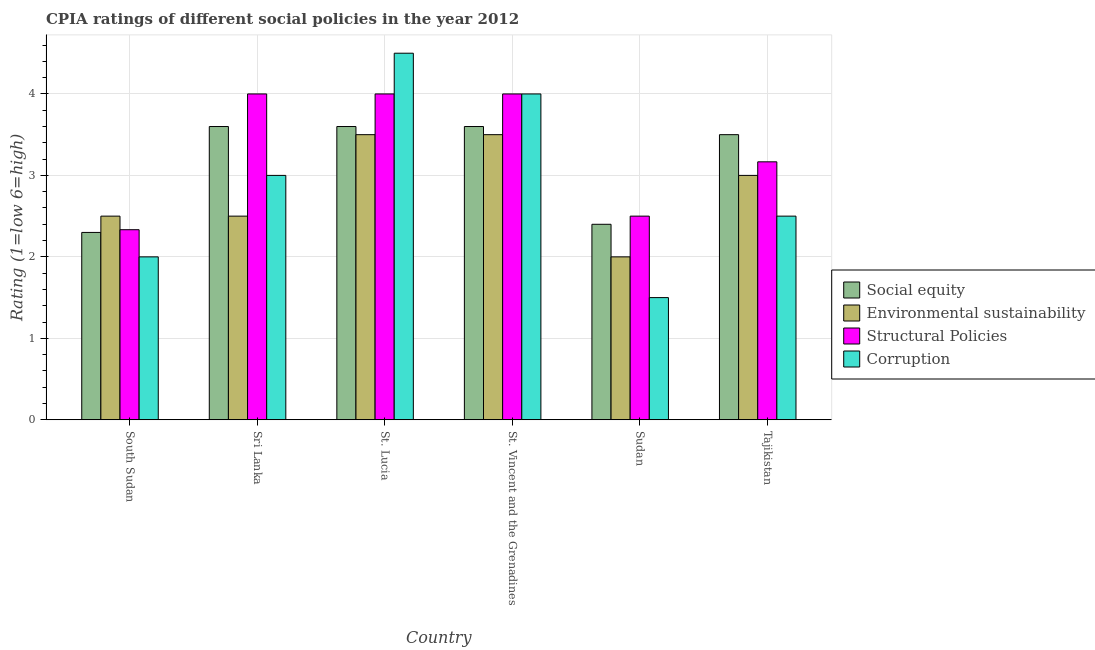How many different coloured bars are there?
Keep it short and to the point. 4. Are the number of bars per tick equal to the number of legend labels?
Your response must be concise. Yes. How many bars are there on the 6th tick from the left?
Your response must be concise. 4. How many bars are there on the 2nd tick from the right?
Your answer should be very brief. 4. What is the label of the 5th group of bars from the left?
Offer a terse response. Sudan. In which country was the cpia rating of structural policies maximum?
Your response must be concise. Sri Lanka. In which country was the cpia rating of social equity minimum?
Give a very brief answer. South Sudan. What is the total cpia rating of environmental sustainability in the graph?
Your response must be concise. 17. What is the difference between the cpia rating of environmental sustainability in Sri Lanka and the cpia rating of corruption in South Sudan?
Your response must be concise. 0.5. What is the average cpia rating of social equity per country?
Provide a short and direct response. 3.17. What is the difference between the cpia rating of social equity and cpia rating of corruption in Sudan?
Your answer should be compact. 0.9. In how many countries, is the cpia rating of structural policies greater than 4.4 ?
Keep it short and to the point. 0. What is the ratio of the cpia rating of social equity in South Sudan to that in St. Lucia?
Ensure brevity in your answer.  0.64. Is the cpia rating of corruption in South Sudan less than that in St. Vincent and the Grenadines?
Your answer should be very brief. Yes. What does the 4th bar from the left in Sri Lanka represents?
Your response must be concise. Corruption. What does the 1st bar from the right in Sudan represents?
Offer a very short reply. Corruption. Is it the case that in every country, the sum of the cpia rating of social equity and cpia rating of environmental sustainability is greater than the cpia rating of structural policies?
Offer a very short reply. Yes. What is the difference between two consecutive major ticks on the Y-axis?
Your answer should be compact. 1. Are the values on the major ticks of Y-axis written in scientific E-notation?
Provide a succinct answer. No. Does the graph contain any zero values?
Make the answer very short. No. Does the graph contain grids?
Give a very brief answer. Yes. How many legend labels are there?
Ensure brevity in your answer.  4. How are the legend labels stacked?
Provide a short and direct response. Vertical. What is the title of the graph?
Your answer should be compact. CPIA ratings of different social policies in the year 2012. Does "Social Protection" appear as one of the legend labels in the graph?
Make the answer very short. No. What is the label or title of the X-axis?
Provide a succinct answer. Country. What is the Rating (1=low 6=high) in Social equity in South Sudan?
Your answer should be very brief. 2.3. What is the Rating (1=low 6=high) of Structural Policies in South Sudan?
Provide a succinct answer. 2.33. What is the Rating (1=low 6=high) in Environmental sustainability in Sri Lanka?
Your answer should be very brief. 2.5. What is the Rating (1=low 6=high) in Corruption in Sri Lanka?
Offer a terse response. 3. What is the Rating (1=low 6=high) of Structural Policies in St. Lucia?
Give a very brief answer. 4. What is the Rating (1=low 6=high) in Environmental sustainability in St. Vincent and the Grenadines?
Ensure brevity in your answer.  3.5. What is the Rating (1=low 6=high) in Environmental sustainability in Sudan?
Offer a terse response. 2. What is the Rating (1=low 6=high) in Structural Policies in Tajikistan?
Keep it short and to the point. 3.17. Across all countries, what is the maximum Rating (1=low 6=high) of Environmental sustainability?
Provide a succinct answer. 3.5. Across all countries, what is the maximum Rating (1=low 6=high) in Structural Policies?
Give a very brief answer. 4. Across all countries, what is the minimum Rating (1=low 6=high) of Environmental sustainability?
Your response must be concise. 2. Across all countries, what is the minimum Rating (1=low 6=high) in Structural Policies?
Provide a short and direct response. 2.33. Across all countries, what is the minimum Rating (1=low 6=high) of Corruption?
Your answer should be compact. 1.5. What is the total Rating (1=low 6=high) of Environmental sustainability in the graph?
Ensure brevity in your answer.  17. What is the total Rating (1=low 6=high) of Structural Policies in the graph?
Offer a terse response. 20. What is the total Rating (1=low 6=high) in Corruption in the graph?
Your answer should be compact. 17.5. What is the difference between the Rating (1=low 6=high) in Structural Policies in South Sudan and that in Sri Lanka?
Offer a very short reply. -1.67. What is the difference between the Rating (1=low 6=high) of Social equity in South Sudan and that in St. Lucia?
Offer a terse response. -1.3. What is the difference between the Rating (1=low 6=high) of Structural Policies in South Sudan and that in St. Lucia?
Your answer should be very brief. -1.67. What is the difference between the Rating (1=low 6=high) in Environmental sustainability in South Sudan and that in St. Vincent and the Grenadines?
Give a very brief answer. -1. What is the difference between the Rating (1=low 6=high) of Structural Policies in South Sudan and that in St. Vincent and the Grenadines?
Your response must be concise. -1.67. What is the difference between the Rating (1=low 6=high) in Corruption in South Sudan and that in St. Vincent and the Grenadines?
Give a very brief answer. -2. What is the difference between the Rating (1=low 6=high) in Social equity in South Sudan and that in Sudan?
Make the answer very short. -0.1. What is the difference between the Rating (1=low 6=high) in Environmental sustainability in South Sudan and that in Sudan?
Provide a short and direct response. 0.5. What is the difference between the Rating (1=low 6=high) of Structural Policies in South Sudan and that in Sudan?
Offer a terse response. -0.17. What is the difference between the Rating (1=low 6=high) of Structural Policies in South Sudan and that in Tajikistan?
Give a very brief answer. -0.83. What is the difference between the Rating (1=low 6=high) of Corruption in South Sudan and that in Tajikistan?
Ensure brevity in your answer.  -0.5. What is the difference between the Rating (1=low 6=high) of Social equity in Sri Lanka and that in St. Lucia?
Ensure brevity in your answer.  0. What is the difference between the Rating (1=low 6=high) in Environmental sustainability in Sri Lanka and that in St. Lucia?
Provide a succinct answer. -1. What is the difference between the Rating (1=low 6=high) of Corruption in Sri Lanka and that in St. Lucia?
Give a very brief answer. -1.5. What is the difference between the Rating (1=low 6=high) in Social equity in Sri Lanka and that in St. Vincent and the Grenadines?
Your answer should be compact. 0. What is the difference between the Rating (1=low 6=high) in Environmental sustainability in Sri Lanka and that in St. Vincent and the Grenadines?
Your answer should be compact. -1. What is the difference between the Rating (1=low 6=high) in Corruption in Sri Lanka and that in St. Vincent and the Grenadines?
Provide a short and direct response. -1. What is the difference between the Rating (1=low 6=high) in Structural Policies in Sri Lanka and that in Sudan?
Keep it short and to the point. 1.5. What is the difference between the Rating (1=low 6=high) of Social equity in Sri Lanka and that in Tajikistan?
Give a very brief answer. 0.1. What is the difference between the Rating (1=low 6=high) in Environmental sustainability in Sri Lanka and that in Tajikistan?
Offer a terse response. -0.5. What is the difference between the Rating (1=low 6=high) of Structural Policies in Sri Lanka and that in Tajikistan?
Give a very brief answer. 0.83. What is the difference between the Rating (1=low 6=high) of Corruption in Sri Lanka and that in Tajikistan?
Give a very brief answer. 0.5. What is the difference between the Rating (1=low 6=high) of Social equity in St. Lucia and that in St. Vincent and the Grenadines?
Ensure brevity in your answer.  0. What is the difference between the Rating (1=low 6=high) in Corruption in St. Lucia and that in St. Vincent and the Grenadines?
Your answer should be very brief. 0.5. What is the difference between the Rating (1=low 6=high) in Social equity in St. Lucia and that in Sudan?
Provide a succinct answer. 1.2. What is the difference between the Rating (1=low 6=high) in Environmental sustainability in St. Lucia and that in Sudan?
Provide a short and direct response. 1.5. What is the difference between the Rating (1=low 6=high) in Corruption in St. Lucia and that in Sudan?
Provide a succinct answer. 3. What is the difference between the Rating (1=low 6=high) in Environmental sustainability in St. Lucia and that in Tajikistan?
Make the answer very short. 0.5. What is the difference between the Rating (1=low 6=high) in Environmental sustainability in St. Vincent and the Grenadines and that in Sudan?
Make the answer very short. 1.5. What is the difference between the Rating (1=low 6=high) in Corruption in St. Vincent and the Grenadines and that in Tajikistan?
Your answer should be compact. 1.5. What is the difference between the Rating (1=low 6=high) of Social equity in Sudan and that in Tajikistan?
Provide a short and direct response. -1.1. What is the difference between the Rating (1=low 6=high) of Environmental sustainability in Sudan and that in Tajikistan?
Provide a short and direct response. -1. What is the difference between the Rating (1=low 6=high) of Structural Policies in Sudan and that in Tajikistan?
Provide a succinct answer. -0.67. What is the difference between the Rating (1=low 6=high) of Corruption in Sudan and that in Tajikistan?
Your response must be concise. -1. What is the difference between the Rating (1=low 6=high) of Social equity in South Sudan and the Rating (1=low 6=high) of Environmental sustainability in Sri Lanka?
Your response must be concise. -0.2. What is the difference between the Rating (1=low 6=high) of Social equity in South Sudan and the Rating (1=low 6=high) of Corruption in Sri Lanka?
Make the answer very short. -0.7. What is the difference between the Rating (1=low 6=high) in Environmental sustainability in South Sudan and the Rating (1=low 6=high) in Corruption in Sri Lanka?
Offer a very short reply. -0.5. What is the difference between the Rating (1=low 6=high) in Structural Policies in South Sudan and the Rating (1=low 6=high) in Corruption in Sri Lanka?
Provide a short and direct response. -0.67. What is the difference between the Rating (1=low 6=high) in Social equity in South Sudan and the Rating (1=low 6=high) in Structural Policies in St. Lucia?
Keep it short and to the point. -1.7. What is the difference between the Rating (1=low 6=high) in Structural Policies in South Sudan and the Rating (1=low 6=high) in Corruption in St. Lucia?
Your response must be concise. -2.17. What is the difference between the Rating (1=low 6=high) of Social equity in South Sudan and the Rating (1=low 6=high) of Corruption in St. Vincent and the Grenadines?
Keep it short and to the point. -1.7. What is the difference between the Rating (1=low 6=high) in Structural Policies in South Sudan and the Rating (1=low 6=high) in Corruption in St. Vincent and the Grenadines?
Your answer should be very brief. -1.67. What is the difference between the Rating (1=low 6=high) in Social equity in South Sudan and the Rating (1=low 6=high) in Environmental sustainability in Sudan?
Make the answer very short. 0.3. What is the difference between the Rating (1=low 6=high) in Environmental sustainability in South Sudan and the Rating (1=low 6=high) in Structural Policies in Sudan?
Offer a very short reply. 0. What is the difference between the Rating (1=low 6=high) in Structural Policies in South Sudan and the Rating (1=low 6=high) in Corruption in Sudan?
Your answer should be compact. 0.83. What is the difference between the Rating (1=low 6=high) of Social equity in South Sudan and the Rating (1=low 6=high) of Environmental sustainability in Tajikistan?
Your answer should be compact. -0.7. What is the difference between the Rating (1=low 6=high) in Social equity in South Sudan and the Rating (1=low 6=high) in Structural Policies in Tajikistan?
Keep it short and to the point. -0.87. What is the difference between the Rating (1=low 6=high) of Structural Policies in South Sudan and the Rating (1=low 6=high) of Corruption in Tajikistan?
Give a very brief answer. -0.17. What is the difference between the Rating (1=low 6=high) in Social equity in Sri Lanka and the Rating (1=low 6=high) in Environmental sustainability in St. Lucia?
Offer a very short reply. 0.1. What is the difference between the Rating (1=low 6=high) in Social equity in Sri Lanka and the Rating (1=low 6=high) in Structural Policies in St. Lucia?
Your answer should be compact. -0.4. What is the difference between the Rating (1=low 6=high) in Environmental sustainability in Sri Lanka and the Rating (1=low 6=high) in Structural Policies in St. Lucia?
Your answer should be compact. -1.5. What is the difference between the Rating (1=low 6=high) of Environmental sustainability in Sri Lanka and the Rating (1=low 6=high) of Corruption in St. Lucia?
Provide a short and direct response. -2. What is the difference between the Rating (1=low 6=high) in Structural Policies in Sri Lanka and the Rating (1=low 6=high) in Corruption in St. Lucia?
Offer a terse response. -0.5. What is the difference between the Rating (1=low 6=high) in Social equity in Sri Lanka and the Rating (1=low 6=high) in Structural Policies in St. Vincent and the Grenadines?
Keep it short and to the point. -0.4. What is the difference between the Rating (1=low 6=high) of Social equity in Sri Lanka and the Rating (1=low 6=high) of Corruption in St. Vincent and the Grenadines?
Provide a short and direct response. -0.4. What is the difference between the Rating (1=low 6=high) of Environmental sustainability in Sri Lanka and the Rating (1=low 6=high) of Structural Policies in St. Vincent and the Grenadines?
Your answer should be very brief. -1.5. What is the difference between the Rating (1=low 6=high) in Structural Policies in Sri Lanka and the Rating (1=low 6=high) in Corruption in St. Vincent and the Grenadines?
Offer a terse response. 0. What is the difference between the Rating (1=low 6=high) of Social equity in Sri Lanka and the Rating (1=low 6=high) of Environmental sustainability in Sudan?
Offer a very short reply. 1.6. What is the difference between the Rating (1=low 6=high) of Social equity in Sri Lanka and the Rating (1=low 6=high) of Structural Policies in Sudan?
Provide a succinct answer. 1.1. What is the difference between the Rating (1=low 6=high) in Environmental sustainability in Sri Lanka and the Rating (1=low 6=high) in Structural Policies in Sudan?
Ensure brevity in your answer.  0. What is the difference between the Rating (1=low 6=high) of Structural Policies in Sri Lanka and the Rating (1=low 6=high) of Corruption in Sudan?
Give a very brief answer. 2.5. What is the difference between the Rating (1=low 6=high) in Social equity in Sri Lanka and the Rating (1=low 6=high) in Structural Policies in Tajikistan?
Your response must be concise. 0.43. What is the difference between the Rating (1=low 6=high) in Social equity in Sri Lanka and the Rating (1=low 6=high) in Corruption in Tajikistan?
Offer a terse response. 1.1. What is the difference between the Rating (1=low 6=high) in Environmental sustainability in Sri Lanka and the Rating (1=low 6=high) in Structural Policies in Tajikistan?
Keep it short and to the point. -0.67. What is the difference between the Rating (1=low 6=high) of Environmental sustainability in Sri Lanka and the Rating (1=low 6=high) of Corruption in Tajikistan?
Make the answer very short. 0. What is the difference between the Rating (1=low 6=high) in Structural Policies in Sri Lanka and the Rating (1=low 6=high) in Corruption in Tajikistan?
Your answer should be compact. 1.5. What is the difference between the Rating (1=low 6=high) in Social equity in St. Lucia and the Rating (1=low 6=high) in Structural Policies in St. Vincent and the Grenadines?
Provide a short and direct response. -0.4. What is the difference between the Rating (1=low 6=high) of Social equity in St. Lucia and the Rating (1=low 6=high) of Corruption in St. Vincent and the Grenadines?
Ensure brevity in your answer.  -0.4. What is the difference between the Rating (1=low 6=high) in Environmental sustainability in St. Lucia and the Rating (1=low 6=high) in Corruption in St. Vincent and the Grenadines?
Make the answer very short. -0.5. What is the difference between the Rating (1=low 6=high) in Social equity in St. Lucia and the Rating (1=low 6=high) in Environmental sustainability in Sudan?
Provide a short and direct response. 1.6. What is the difference between the Rating (1=low 6=high) in Social equity in St. Lucia and the Rating (1=low 6=high) in Structural Policies in Tajikistan?
Ensure brevity in your answer.  0.43. What is the difference between the Rating (1=low 6=high) of Social equity in St. Lucia and the Rating (1=low 6=high) of Corruption in Tajikistan?
Your response must be concise. 1.1. What is the difference between the Rating (1=low 6=high) of Social equity in St. Vincent and the Grenadines and the Rating (1=low 6=high) of Environmental sustainability in Sudan?
Give a very brief answer. 1.6. What is the difference between the Rating (1=low 6=high) of Social equity in St. Vincent and the Grenadines and the Rating (1=low 6=high) of Structural Policies in Sudan?
Provide a succinct answer. 1.1. What is the difference between the Rating (1=low 6=high) of Social equity in St. Vincent and the Grenadines and the Rating (1=low 6=high) of Structural Policies in Tajikistan?
Provide a short and direct response. 0.43. What is the difference between the Rating (1=low 6=high) in Environmental sustainability in St. Vincent and the Grenadines and the Rating (1=low 6=high) in Structural Policies in Tajikistan?
Your answer should be compact. 0.33. What is the difference between the Rating (1=low 6=high) in Environmental sustainability in St. Vincent and the Grenadines and the Rating (1=low 6=high) in Corruption in Tajikistan?
Ensure brevity in your answer.  1. What is the difference between the Rating (1=low 6=high) of Structural Policies in St. Vincent and the Grenadines and the Rating (1=low 6=high) of Corruption in Tajikistan?
Your answer should be very brief. 1.5. What is the difference between the Rating (1=low 6=high) of Social equity in Sudan and the Rating (1=low 6=high) of Environmental sustainability in Tajikistan?
Your answer should be compact. -0.6. What is the difference between the Rating (1=low 6=high) of Social equity in Sudan and the Rating (1=low 6=high) of Structural Policies in Tajikistan?
Offer a very short reply. -0.77. What is the difference between the Rating (1=low 6=high) in Environmental sustainability in Sudan and the Rating (1=low 6=high) in Structural Policies in Tajikistan?
Provide a short and direct response. -1.17. What is the difference between the Rating (1=low 6=high) in Environmental sustainability in Sudan and the Rating (1=low 6=high) in Corruption in Tajikistan?
Provide a succinct answer. -0.5. What is the difference between the Rating (1=low 6=high) in Structural Policies in Sudan and the Rating (1=low 6=high) in Corruption in Tajikistan?
Your answer should be compact. 0. What is the average Rating (1=low 6=high) of Social equity per country?
Give a very brief answer. 3.17. What is the average Rating (1=low 6=high) in Environmental sustainability per country?
Offer a very short reply. 2.83. What is the average Rating (1=low 6=high) of Corruption per country?
Offer a terse response. 2.92. What is the difference between the Rating (1=low 6=high) of Social equity and Rating (1=low 6=high) of Environmental sustainability in South Sudan?
Give a very brief answer. -0.2. What is the difference between the Rating (1=low 6=high) of Social equity and Rating (1=low 6=high) of Structural Policies in South Sudan?
Provide a short and direct response. -0.03. What is the difference between the Rating (1=low 6=high) in Environmental sustainability and Rating (1=low 6=high) in Structural Policies in South Sudan?
Offer a very short reply. 0.17. What is the difference between the Rating (1=low 6=high) of Environmental sustainability and Rating (1=low 6=high) of Corruption in South Sudan?
Your response must be concise. 0.5. What is the difference between the Rating (1=low 6=high) of Social equity and Rating (1=low 6=high) of Structural Policies in Sri Lanka?
Keep it short and to the point. -0.4. What is the difference between the Rating (1=low 6=high) of Social equity and Rating (1=low 6=high) of Environmental sustainability in St. Lucia?
Offer a terse response. 0.1. What is the difference between the Rating (1=low 6=high) in Social equity and Rating (1=low 6=high) in Structural Policies in St. Lucia?
Offer a terse response. -0.4. What is the difference between the Rating (1=low 6=high) of Social equity and Rating (1=low 6=high) of Corruption in St. Lucia?
Provide a succinct answer. -0.9. What is the difference between the Rating (1=low 6=high) of Environmental sustainability and Rating (1=low 6=high) of Structural Policies in St. Vincent and the Grenadines?
Provide a succinct answer. -0.5. What is the difference between the Rating (1=low 6=high) in Environmental sustainability and Rating (1=low 6=high) in Corruption in St. Vincent and the Grenadines?
Offer a very short reply. -0.5. What is the difference between the Rating (1=low 6=high) of Social equity and Rating (1=low 6=high) of Environmental sustainability in Sudan?
Offer a very short reply. 0.4. What is the difference between the Rating (1=low 6=high) in Social equity and Rating (1=low 6=high) in Corruption in Sudan?
Offer a terse response. 0.9. What is the difference between the Rating (1=low 6=high) of Environmental sustainability and Rating (1=low 6=high) of Structural Policies in Sudan?
Offer a very short reply. -0.5. What is the difference between the Rating (1=low 6=high) in Social equity and Rating (1=low 6=high) in Corruption in Tajikistan?
Offer a terse response. 1. What is the difference between the Rating (1=low 6=high) of Environmental sustainability and Rating (1=low 6=high) of Structural Policies in Tajikistan?
Give a very brief answer. -0.17. What is the difference between the Rating (1=low 6=high) in Environmental sustainability and Rating (1=low 6=high) in Corruption in Tajikistan?
Offer a terse response. 0.5. What is the difference between the Rating (1=low 6=high) of Structural Policies and Rating (1=low 6=high) of Corruption in Tajikistan?
Keep it short and to the point. 0.67. What is the ratio of the Rating (1=low 6=high) of Social equity in South Sudan to that in Sri Lanka?
Keep it short and to the point. 0.64. What is the ratio of the Rating (1=low 6=high) of Structural Policies in South Sudan to that in Sri Lanka?
Your response must be concise. 0.58. What is the ratio of the Rating (1=low 6=high) in Social equity in South Sudan to that in St. Lucia?
Ensure brevity in your answer.  0.64. What is the ratio of the Rating (1=low 6=high) in Environmental sustainability in South Sudan to that in St. Lucia?
Ensure brevity in your answer.  0.71. What is the ratio of the Rating (1=low 6=high) in Structural Policies in South Sudan to that in St. Lucia?
Keep it short and to the point. 0.58. What is the ratio of the Rating (1=low 6=high) of Corruption in South Sudan to that in St. Lucia?
Your response must be concise. 0.44. What is the ratio of the Rating (1=low 6=high) in Social equity in South Sudan to that in St. Vincent and the Grenadines?
Keep it short and to the point. 0.64. What is the ratio of the Rating (1=low 6=high) of Environmental sustainability in South Sudan to that in St. Vincent and the Grenadines?
Provide a short and direct response. 0.71. What is the ratio of the Rating (1=low 6=high) in Structural Policies in South Sudan to that in St. Vincent and the Grenadines?
Ensure brevity in your answer.  0.58. What is the ratio of the Rating (1=low 6=high) of Corruption in South Sudan to that in St. Vincent and the Grenadines?
Keep it short and to the point. 0.5. What is the ratio of the Rating (1=low 6=high) of Structural Policies in South Sudan to that in Sudan?
Ensure brevity in your answer.  0.93. What is the ratio of the Rating (1=low 6=high) in Social equity in South Sudan to that in Tajikistan?
Ensure brevity in your answer.  0.66. What is the ratio of the Rating (1=low 6=high) of Environmental sustainability in South Sudan to that in Tajikistan?
Your answer should be compact. 0.83. What is the ratio of the Rating (1=low 6=high) in Structural Policies in South Sudan to that in Tajikistan?
Your answer should be very brief. 0.74. What is the ratio of the Rating (1=low 6=high) of Corruption in South Sudan to that in Tajikistan?
Your response must be concise. 0.8. What is the ratio of the Rating (1=low 6=high) of Social equity in Sri Lanka to that in St. Lucia?
Your answer should be compact. 1. What is the ratio of the Rating (1=low 6=high) of Structural Policies in Sri Lanka to that in St. Lucia?
Make the answer very short. 1. What is the ratio of the Rating (1=low 6=high) in Environmental sustainability in Sri Lanka to that in Sudan?
Provide a succinct answer. 1.25. What is the ratio of the Rating (1=low 6=high) in Social equity in Sri Lanka to that in Tajikistan?
Provide a succinct answer. 1.03. What is the ratio of the Rating (1=low 6=high) of Environmental sustainability in Sri Lanka to that in Tajikistan?
Your answer should be compact. 0.83. What is the ratio of the Rating (1=low 6=high) in Structural Policies in Sri Lanka to that in Tajikistan?
Keep it short and to the point. 1.26. What is the ratio of the Rating (1=low 6=high) in Social equity in St. Lucia to that in St. Vincent and the Grenadines?
Make the answer very short. 1. What is the ratio of the Rating (1=low 6=high) of Environmental sustainability in St. Lucia to that in St. Vincent and the Grenadines?
Offer a terse response. 1. What is the ratio of the Rating (1=low 6=high) in Structural Policies in St. Lucia to that in St. Vincent and the Grenadines?
Keep it short and to the point. 1. What is the ratio of the Rating (1=low 6=high) in Corruption in St. Lucia to that in St. Vincent and the Grenadines?
Your response must be concise. 1.12. What is the ratio of the Rating (1=low 6=high) of Social equity in St. Lucia to that in Sudan?
Ensure brevity in your answer.  1.5. What is the ratio of the Rating (1=low 6=high) in Social equity in St. Lucia to that in Tajikistan?
Provide a short and direct response. 1.03. What is the ratio of the Rating (1=low 6=high) in Structural Policies in St. Lucia to that in Tajikistan?
Your answer should be compact. 1.26. What is the ratio of the Rating (1=low 6=high) in Corruption in St. Lucia to that in Tajikistan?
Offer a very short reply. 1.8. What is the ratio of the Rating (1=low 6=high) in Environmental sustainability in St. Vincent and the Grenadines to that in Sudan?
Keep it short and to the point. 1.75. What is the ratio of the Rating (1=low 6=high) of Structural Policies in St. Vincent and the Grenadines to that in Sudan?
Your response must be concise. 1.6. What is the ratio of the Rating (1=low 6=high) in Corruption in St. Vincent and the Grenadines to that in Sudan?
Give a very brief answer. 2.67. What is the ratio of the Rating (1=low 6=high) in Social equity in St. Vincent and the Grenadines to that in Tajikistan?
Your answer should be compact. 1.03. What is the ratio of the Rating (1=low 6=high) in Environmental sustainability in St. Vincent and the Grenadines to that in Tajikistan?
Offer a terse response. 1.17. What is the ratio of the Rating (1=low 6=high) in Structural Policies in St. Vincent and the Grenadines to that in Tajikistan?
Keep it short and to the point. 1.26. What is the ratio of the Rating (1=low 6=high) of Social equity in Sudan to that in Tajikistan?
Provide a succinct answer. 0.69. What is the ratio of the Rating (1=low 6=high) in Structural Policies in Sudan to that in Tajikistan?
Provide a short and direct response. 0.79. What is the difference between the highest and the second highest Rating (1=low 6=high) of Social equity?
Make the answer very short. 0. What is the difference between the highest and the second highest Rating (1=low 6=high) of Environmental sustainability?
Keep it short and to the point. 0. What is the difference between the highest and the second highest Rating (1=low 6=high) of Corruption?
Provide a succinct answer. 0.5. What is the difference between the highest and the lowest Rating (1=low 6=high) of Environmental sustainability?
Your answer should be compact. 1.5. What is the difference between the highest and the lowest Rating (1=low 6=high) in Structural Policies?
Give a very brief answer. 1.67. 